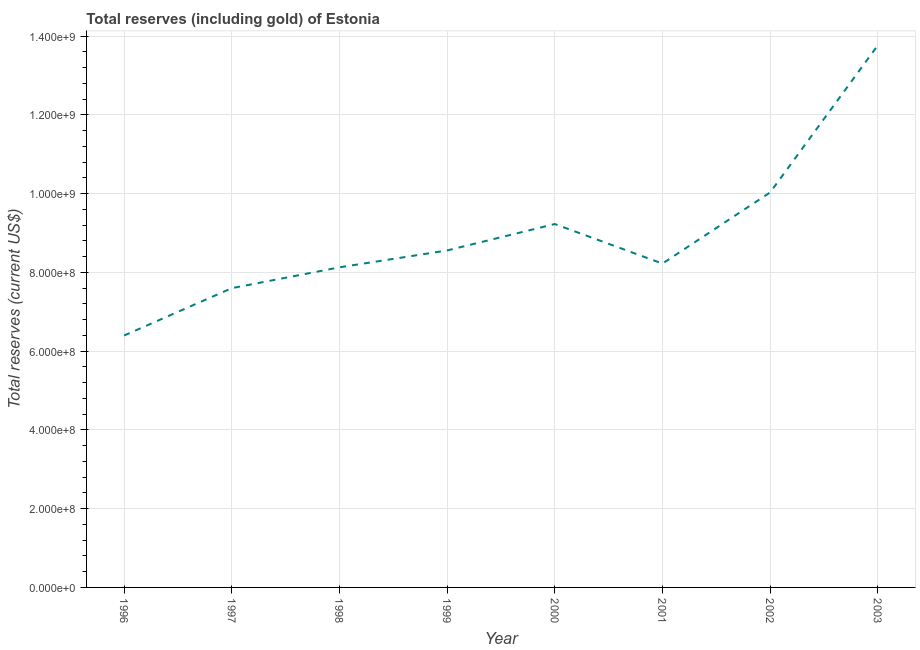What is the total reserves (including gold) in 1998?
Your response must be concise. 8.13e+08. Across all years, what is the maximum total reserves (including gold)?
Offer a terse response. 1.38e+09. Across all years, what is the minimum total reserves (including gold)?
Your response must be concise. 6.40e+08. In which year was the total reserves (including gold) minimum?
Provide a short and direct response. 1996. What is the sum of the total reserves (including gold)?
Offer a terse response. 7.19e+09. What is the difference between the total reserves (including gold) in 1996 and 2003?
Keep it short and to the point. -7.37e+08. What is the average total reserves (including gold) per year?
Provide a short and direct response. 8.99e+08. What is the median total reserves (including gold)?
Your response must be concise. 8.39e+08. In how many years, is the total reserves (including gold) greater than 920000000 US$?
Your answer should be very brief. 3. Do a majority of the years between 1999 and 1996 (inclusive) have total reserves (including gold) greater than 1320000000 US$?
Offer a terse response. Yes. What is the ratio of the total reserves (including gold) in 1999 to that in 2001?
Your response must be concise. 1.04. Is the total reserves (including gold) in 2000 less than that in 2001?
Your answer should be very brief. No. What is the difference between the highest and the second highest total reserves (including gold)?
Keep it short and to the point. 3.74e+08. Is the sum of the total reserves (including gold) in 1999 and 2002 greater than the maximum total reserves (including gold) across all years?
Provide a short and direct response. Yes. What is the difference between the highest and the lowest total reserves (including gold)?
Provide a succinct answer. 7.37e+08. Does the total reserves (including gold) monotonically increase over the years?
Offer a terse response. No. How many lines are there?
Offer a terse response. 1. How many years are there in the graph?
Offer a terse response. 8. What is the title of the graph?
Ensure brevity in your answer.  Total reserves (including gold) of Estonia. What is the label or title of the X-axis?
Offer a very short reply. Year. What is the label or title of the Y-axis?
Provide a short and direct response. Total reserves (current US$). What is the Total reserves (current US$) in 1996?
Ensure brevity in your answer.  6.40e+08. What is the Total reserves (current US$) in 1997?
Give a very brief answer. 7.60e+08. What is the Total reserves (current US$) in 1998?
Provide a short and direct response. 8.13e+08. What is the Total reserves (current US$) of 1999?
Offer a very short reply. 8.56e+08. What is the Total reserves (current US$) in 2000?
Your response must be concise. 9.23e+08. What is the Total reserves (current US$) in 2001?
Ensure brevity in your answer.  8.22e+08. What is the Total reserves (current US$) of 2002?
Give a very brief answer. 1.00e+09. What is the Total reserves (current US$) of 2003?
Provide a short and direct response. 1.38e+09. What is the difference between the Total reserves (current US$) in 1996 and 1997?
Ensure brevity in your answer.  -1.20e+08. What is the difference between the Total reserves (current US$) in 1996 and 1998?
Provide a short and direct response. -1.73e+08. What is the difference between the Total reserves (current US$) in 1996 and 1999?
Make the answer very short. -2.16e+08. What is the difference between the Total reserves (current US$) in 1996 and 2000?
Ensure brevity in your answer.  -2.83e+08. What is the difference between the Total reserves (current US$) in 1996 and 2001?
Provide a short and direct response. -1.83e+08. What is the difference between the Total reserves (current US$) in 1996 and 2002?
Offer a very short reply. -3.63e+08. What is the difference between the Total reserves (current US$) in 1996 and 2003?
Offer a terse response. -7.37e+08. What is the difference between the Total reserves (current US$) in 1997 and 1998?
Ensure brevity in your answer.  -5.29e+07. What is the difference between the Total reserves (current US$) in 1997 and 1999?
Your response must be concise. -9.58e+07. What is the difference between the Total reserves (current US$) in 1997 and 2000?
Offer a very short reply. -1.63e+08. What is the difference between the Total reserves (current US$) in 1997 and 2001?
Your answer should be compact. -6.24e+07. What is the difference between the Total reserves (current US$) in 1997 and 2002?
Your answer should be very brief. -2.43e+08. What is the difference between the Total reserves (current US$) in 1997 and 2003?
Offer a very short reply. -6.17e+08. What is the difference between the Total reserves (current US$) in 1998 and 1999?
Keep it short and to the point. -4.29e+07. What is the difference between the Total reserves (current US$) in 1998 and 2000?
Provide a short and direct response. -1.10e+08. What is the difference between the Total reserves (current US$) in 1998 and 2001?
Give a very brief answer. -9.55e+06. What is the difference between the Total reserves (current US$) in 1998 and 2002?
Give a very brief answer. -1.90e+08. What is the difference between the Total reserves (current US$) in 1998 and 2003?
Offer a terse response. -5.64e+08. What is the difference between the Total reserves (current US$) in 1999 and 2000?
Give a very brief answer. -6.70e+07. What is the difference between the Total reserves (current US$) in 1999 and 2001?
Give a very brief answer. 3.34e+07. What is the difference between the Total reserves (current US$) in 1999 and 2002?
Keep it short and to the point. -1.47e+08. What is the difference between the Total reserves (current US$) in 1999 and 2003?
Ensure brevity in your answer.  -5.21e+08. What is the difference between the Total reserves (current US$) in 2000 and 2001?
Provide a short and direct response. 1.00e+08. What is the difference between the Total reserves (current US$) in 2000 and 2002?
Make the answer very short. -8.03e+07. What is the difference between the Total reserves (current US$) in 2000 and 2003?
Offer a terse response. -4.54e+08. What is the difference between the Total reserves (current US$) in 2001 and 2002?
Give a very brief answer. -1.81e+08. What is the difference between the Total reserves (current US$) in 2001 and 2003?
Give a very brief answer. -5.54e+08. What is the difference between the Total reserves (current US$) in 2002 and 2003?
Provide a succinct answer. -3.74e+08. What is the ratio of the Total reserves (current US$) in 1996 to that in 1997?
Offer a very short reply. 0.84. What is the ratio of the Total reserves (current US$) in 1996 to that in 1998?
Ensure brevity in your answer.  0.79. What is the ratio of the Total reserves (current US$) in 1996 to that in 1999?
Your answer should be compact. 0.75. What is the ratio of the Total reserves (current US$) in 1996 to that in 2000?
Offer a very short reply. 0.69. What is the ratio of the Total reserves (current US$) in 1996 to that in 2001?
Your response must be concise. 0.78. What is the ratio of the Total reserves (current US$) in 1996 to that in 2002?
Provide a succinct answer. 0.64. What is the ratio of the Total reserves (current US$) in 1996 to that in 2003?
Give a very brief answer. 0.47. What is the ratio of the Total reserves (current US$) in 1997 to that in 1998?
Ensure brevity in your answer.  0.94. What is the ratio of the Total reserves (current US$) in 1997 to that in 1999?
Offer a terse response. 0.89. What is the ratio of the Total reserves (current US$) in 1997 to that in 2000?
Your response must be concise. 0.82. What is the ratio of the Total reserves (current US$) in 1997 to that in 2001?
Offer a terse response. 0.92. What is the ratio of the Total reserves (current US$) in 1997 to that in 2002?
Keep it short and to the point. 0.76. What is the ratio of the Total reserves (current US$) in 1997 to that in 2003?
Make the answer very short. 0.55. What is the ratio of the Total reserves (current US$) in 1998 to that in 1999?
Your answer should be compact. 0.95. What is the ratio of the Total reserves (current US$) in 1998 to that in 2000?
Keep it short and to the point. 0.88. What is the ratio of the Total reserves (current US$) in 1998 to that in 2001?
Give a very brief answer. 0.99. What is the ratio of the Total reserves (current US$) in 1998 to that in 2002?
Provide a short and direct response. 0.81. What is the ratio of the Total reserves (current US$) in 1998 to that in 2003?
Your answer should be very brief. 0.59. What is the ratio of the Total reserves (current US$) in 1999 to that in 2000?
Ensure brevity in your answer.  0.93. What is the ratio of the Total reserves (current US$) in 1999 to that in 2001?
Offer a very short reply. 1.04. What is the ratio of the Total reserves (current US$) in 1999 to that in 2002?
Keep it short and to the point. 0.85. What is the ratio of the Total reserves (current US$) in 1999 to that in 2003?
Provide a succinct answer. 0.62. What is the ratio of the Total reserves (current US$) in 2000 to that in 2001?
Your answer should be very brief. 1.12. What is the ratio of the Total reserves (current US$) in 2000 to that in 2002?
Provide a succinct answer. 0.92. What is the ratio of the Total reserves (current US$) in 2000 to that in 2003?
Your response must be concise. 0.67. What is the ratio of the Total reserves (current US$) in 2001 to that in 2002?
Give a very brief answer. 0.82. What is the ratio of the Total reserves (current US$) in 2001 to that in 2003?
Ensure brevity in your answer.  0.6. What is the ratio of the Total reserves (current US$) in 2002 to that in 2003?
Your response must be concise. 0.73. 